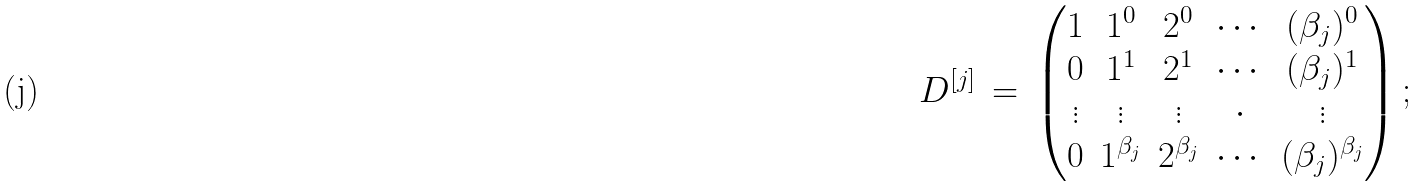<formula> <loc_0><loc_0><loc_500><loc_500>D ^ { [ j ] } \, = \, \begin{pmatrix} 1 & 1 ^ { 0 } & 2 ^ { 0 } & \cdots & ( \beta _ { j } ) ^ { 0 } \\ 0 & 1 ^ { 1 } & 2 ^ { 1 } & \cdots & ( \beta _ { j } ) ^ { 1 } \\ \vdots & \vdots & \vdots & \cdot & \vdots \\ 0 & 1 ^ { \beta _ { j } } & 2 ^ { \beta _ { j } } & \cdots & ( \beta _ { j } ) ^ { \beta _ { j } } \end{pmatrix} ;</formula> 